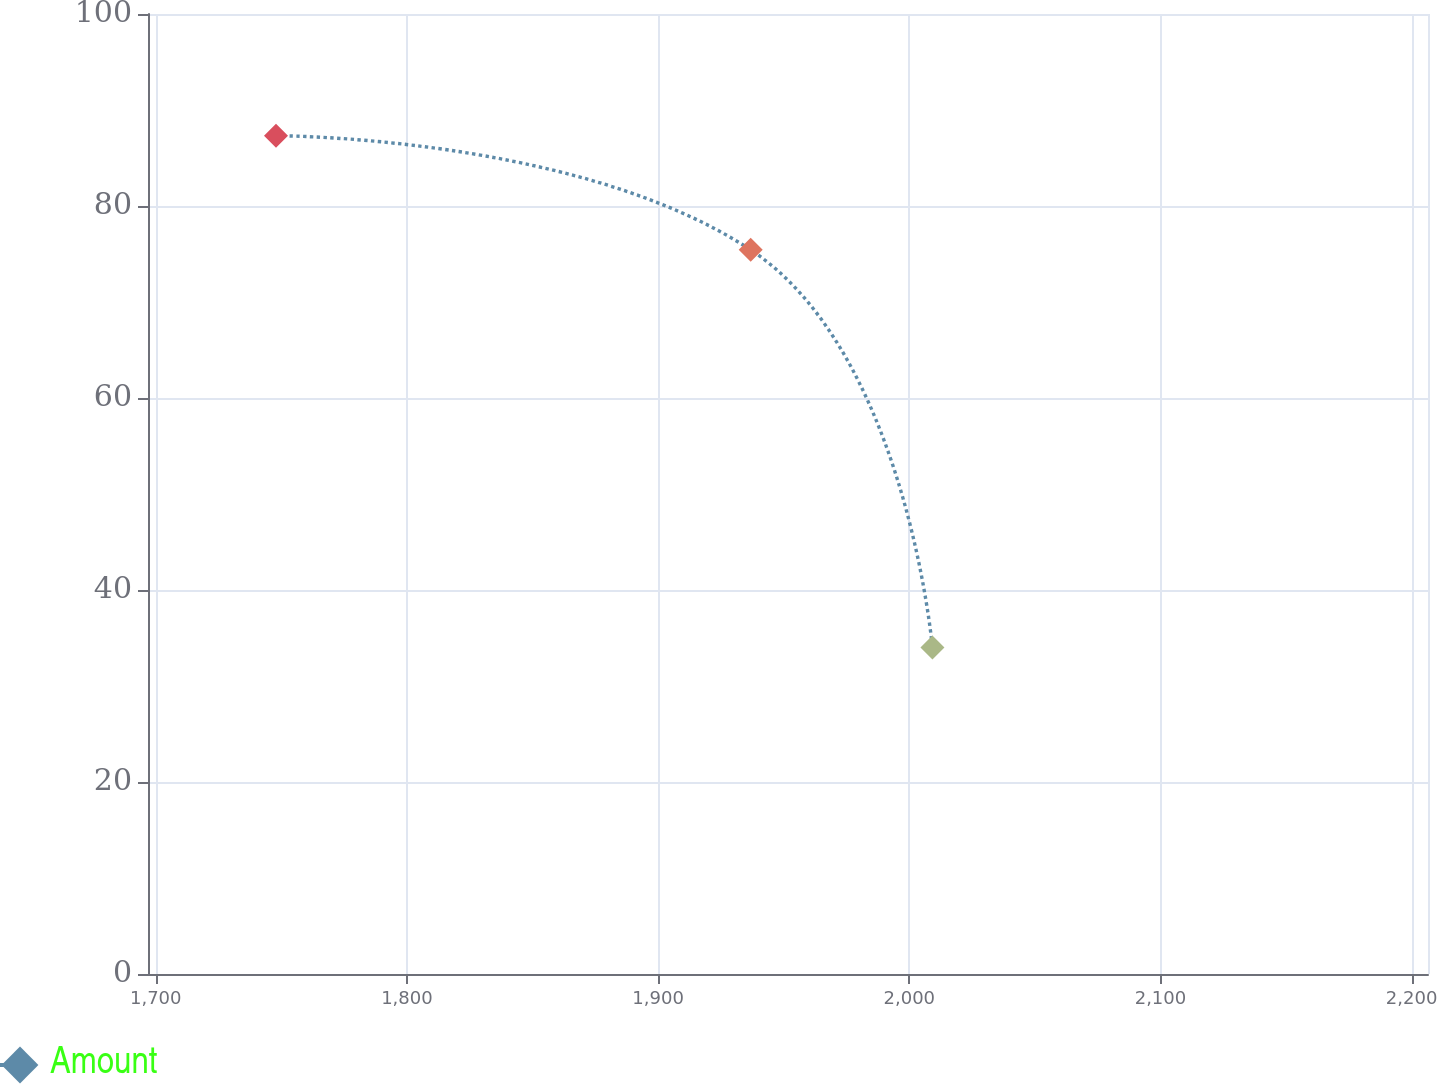<chart> <loc_0><loc_0><loc_500><loc_500><line_chart><ecel><fcel>Amount<nl><fcel>1747.87<fcel>87.32<nl><fcel>1936.86<fcel>75.43<nl><fcel>2009.22<fcel>34<nl><fcel>2210.41<fcel>26.46<nl><fcel>2257.48<fcel>11.91<nl></chart> 